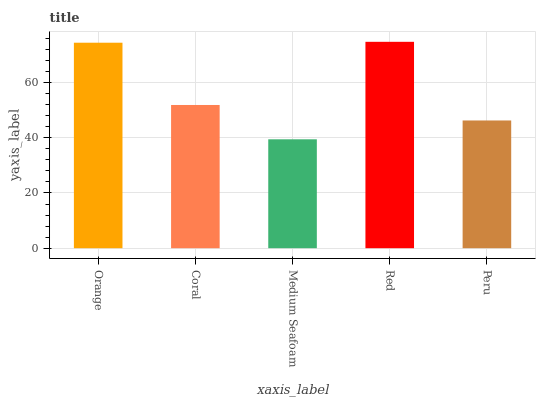Is Medium Seafoam the minimum?
Answer yes or no. Yes. Is Red the maximum?
Answer yes or no. Yes. Is Coral the minimum?
Answer yes or no. No. Is Coral the maximum?
Answer yes or no. No. Is Orange greater than Coral?
Answer yes or no. Yes. Is Coral less than Orange?
Answer yes or no. Yes. Is Coral greater than Orange?
Answer yes or no. No. Is Orange less than Coral?
Answer yes or no. No. Is Coral the high median?
Answer yes or no. Yes. Is Coral the low median?
Answer yes or no. Yes. Is Red the high median?
Answer yes or no. No. Is Orange the low median?
Answer yes or no. No. 